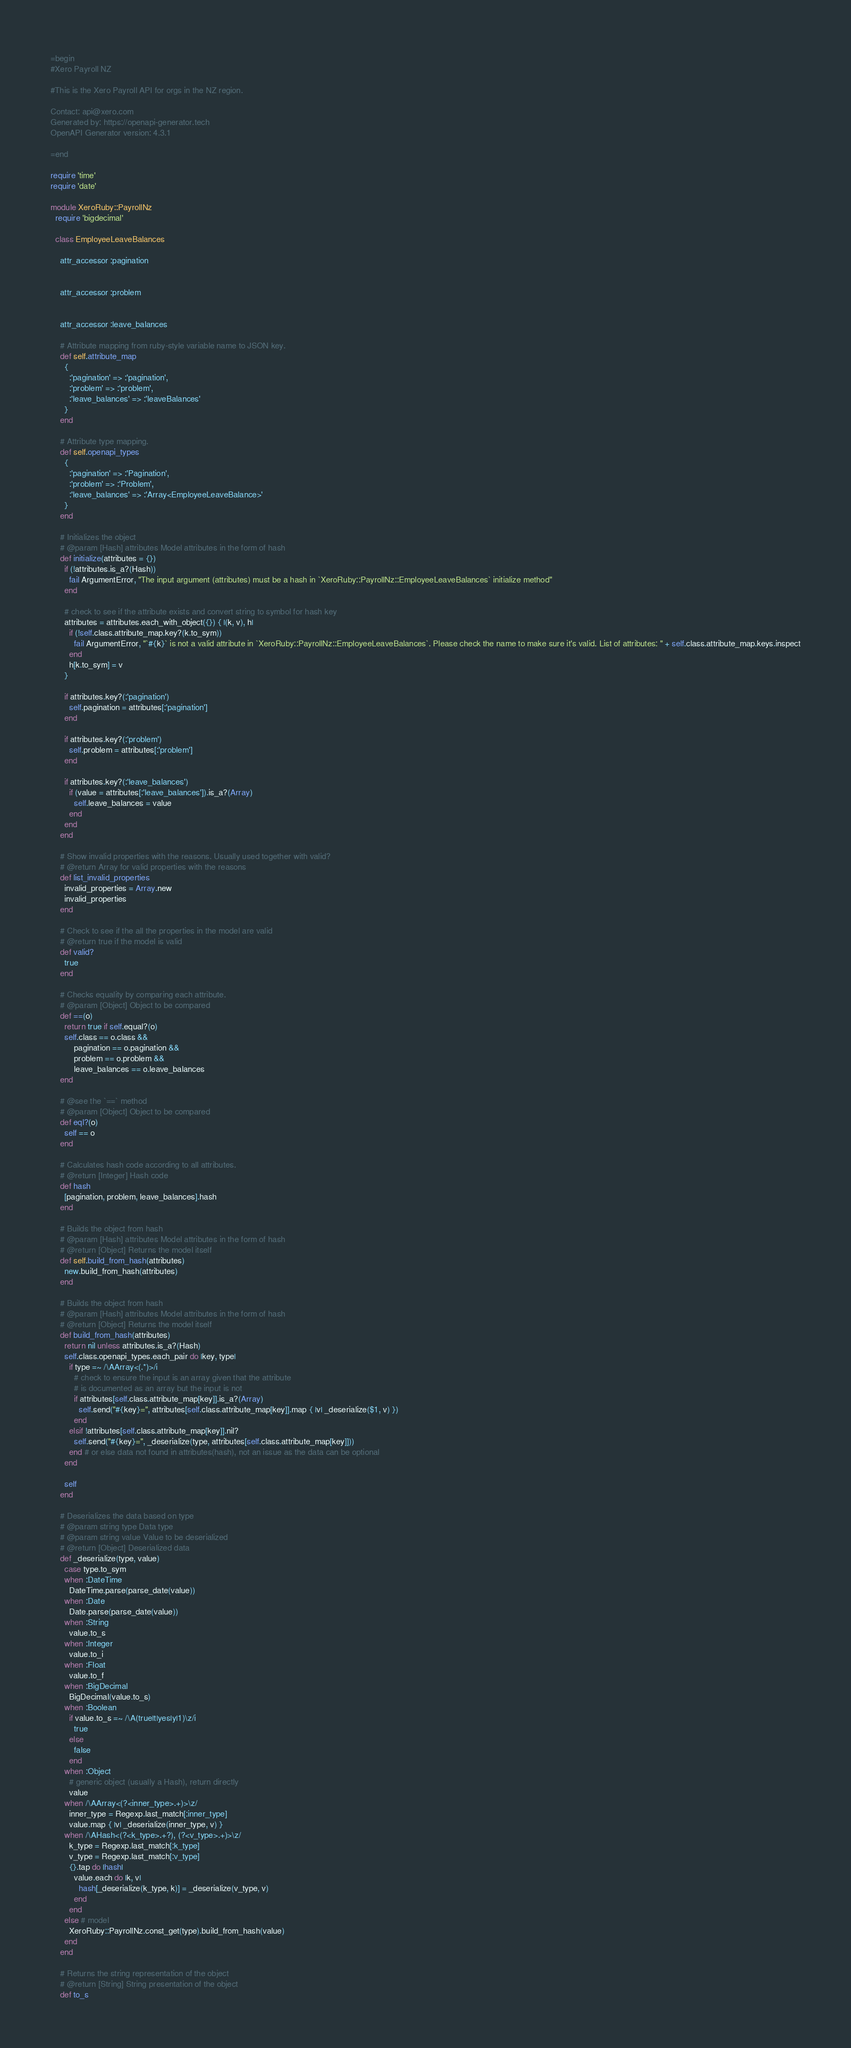<code> <loc_0><loc_0><loc_500><loc_500><_Ruby_>=begin
#Xero Payroll NZ

#This is the Xero Payroll API for orgs in the NZ region.

Contact: api@xero.com
Generated by: https://openapi-generator.tech
OpenAPI Generator version: 4.3.1

=end

require 'time'
require 'date'

module XeroRuby::PayrollNz
  require 'bigdecimal'

  class EmployeeLeaveBalances

    attr_accessor :pagination
    

    attr_accessor :problem
    

    attr_accessor :leave_balances
    
    # Attribute mapping from ruby-style variable name to JSON key.
    def self.attribute_map
      {
        :'pagination' => :'pagination',
        :'problem' => :'problem',
        :'leave_balances' => :'leaveBalances'
      }
    end

    # Attribute type mapping.
    def self.openapi_types
      {
        :'pagination' => :'Pagination',
        :'problem' => :'Problem',
        :'leave_balances' => :'Array<EmployeeLeaveBalance>'
      }
    end

    # Initializes the object
    # @param [Hash] attributes Model attributes in the form of hash
    def initialize(attributes = {})
      if (!attributes.is_a?(Hash))
        fail ArgumentError, "The input argument (attributes) must be a hash in `XeroRuby::PayrollNz::EmployeeLeaveBalances` initialize method"
      end

      # check to see if the attribute exists and convert string to symbol for hash key
      attributes = attributes.each_with_object({}) { |(k, v), h|
        if (!self.class.attribute_map.key?(k.to_sym))
          fail ArgumentError, "`#{k}` is not a valid attribute in `XeroRuby::PayrollNz::EmployeeLeaveBalances`. Please check the name to make sure it's valid. List of attributes: " + self.class.attribute_map.keys.inspect
        end
        h[k.to_sym] = v
      }

      if attributes.key?(:'pagination')
        self.pagination = attributes[:'pagination']
      end

      if attributes.key?(:'problem')
        self.problem = attributes[:'problem']
      end

      if attributes.key?(:'leave_balances')
        if (value = attributes[:'leave_balances']).is_a?(Array)
          self.leave_balances = value
        end
      end
    end

    # Show invalid properties with the reasons. Usually used together with valid?
    # @return Array for valid properties with the reasons
    def list_invalid_properties
      invalid_properties = Array.new
      invalid_properties
    end

    # Check to see if the all the properties in the model are valid
    # @return true if the model is valid
    def valid?
      true
    end

    # Checks equality by comparing each attribute.
    # @param [Object] Object to be compared
    def ==(o)
      return true if self.equal?(o)
      self.class == o.class &&
          pagination == o.pagination &&
          problem == o.problem &&
          leave_balances == o.leave_balances
    end

    # @see the `==` method
    # @param [Object] Object to be compared
    def eql?(o)
      self == o
    end

    # Calculates hash code according to all attributes.
    # @return [Integer] Hash code
    def hash
      [pagination, problem, leave_balances].hash
    end

    # Builds the object from hash
    # @param [Hash] attributes Model attributes in the form of hash
    # @return [Object] Returns the model itself
    def self.build_from_hash(attributes)
      new.build_from_hash(attributes)
    end

    # Builds the object from hash
    # @param [Hash] attributes Model attributes in the form of hash
    # @return [Object] Returns the model itself
    def build_from_hash(attributes)
      return nil unless attributes.is_a?(Hash)
      self.class.openapi_types.each_pair do |key, type|
        if type =~ /\AArray<(.*)>/i
          # check to ensure the input is an array given that the attribute
          # is documented as an array but the input is not
          if attributes[self.class.attribute_map[key]].is_a?(Array)
            self.send("#{key}=", attributes[self.class.attribute_map[key]].map { |v| _deserialize($1, v) })
          end
        elsif !attributes[self.class.attribute_map[key]].nil?
          self.send("#{key}=", _deserialize(type, attributes[self.class.attribute_map[key]]))
        end # or else data not found in attributes(hash), not an issue as the data can be optional
      end

      self
    end

    # Deserializes the data based on type
    # @param string type Data type
    # @param string value Value to be deserialized
    # @return [Object] Deserialized data
    def _deserialize(type, value)
      case type.to_sym
      when :DateTime
        DateTime.parse(parse_date(value))
      when :Date
        Date.parse(parse_date(value))
      when :String
        value.to_s
      when :Integer
        value.to_i
      when :Float
        value.to_f
      when :BigDecimal
        BigDecimal(value.to_s)
      when :Boolean
        if value.to_s =~ /\A(true|t|yes|y|1)\z/i
          true
        else
          false
        end
      when :Object
        # generic object (usually a Hash), return directly
        value
      when /\AArray<(?<inner_type>.+)>\z/
        inner_type = Regexp.last_match[:inner_type]
        value.map { |v| _deserialize(inner_type, v) }
      when /\AHash<(?<k_type>.+?), (?<v_type>.+)>\z/
        k_type = Regexp.last_match[:k_type]
        v_type = Regexp.last_match[:v_type]
        {}.tap do |hash|
          value.each do |k, v|
            hash[_deserialize(k_type, k)] = _deserialize(v_type, v)
          end
        end
      else # model
        XeroRuby::PayrollNz.const_get(type).build_from_hash(value)
      end
    end

    # Returns the string representation of the object
    # @return [String] String presentation of the object
    def to_s</code> 